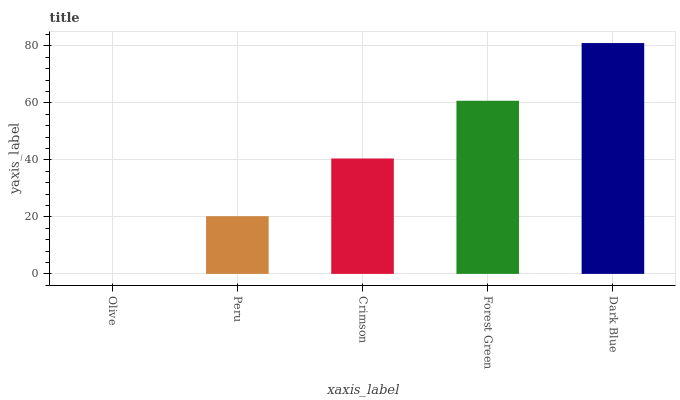Is Olive the minimum?
Answer yes or no. Yes. Is Dark Blue the maximum?
Answer yes or no. Yes. Is Peru the minimum?
Answer yes or no. No. Is Peru the maximum?
Answer yes or no. No. Is Peru greater than Olive?
Answer yes or no. Yes. Is Olive less than Peru?
Answer yes or no. Yes. Is Olive greater than Peru?
Answer yes or no. No. Is Peru less than Olive?
Answer yes or no. No. Is Crimson the high median?
Answer yes or no. Yes. Is Crimson the low median?
Answer yes or no. Yes. Is Olive the high median?
Answer yes or no. No. Is Forest Green the low median?
Answer yes or no. No. 